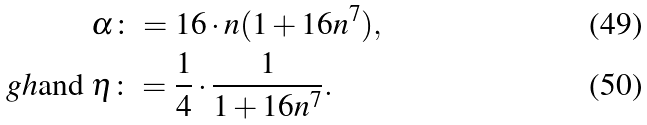<formula> <loc_0><loc_0><loc_500><loc_500>& \alpha \colon = 1 6 \cdot n ( 1 + 1 6 n ^ { 7 } ) , \\ \ g h { \text {and } } & \eta \colon = \frac { 1 } { 4 } \cdot \frac { 1 } { 1 + 1 6 n ^ { 7 } } .</formula> 